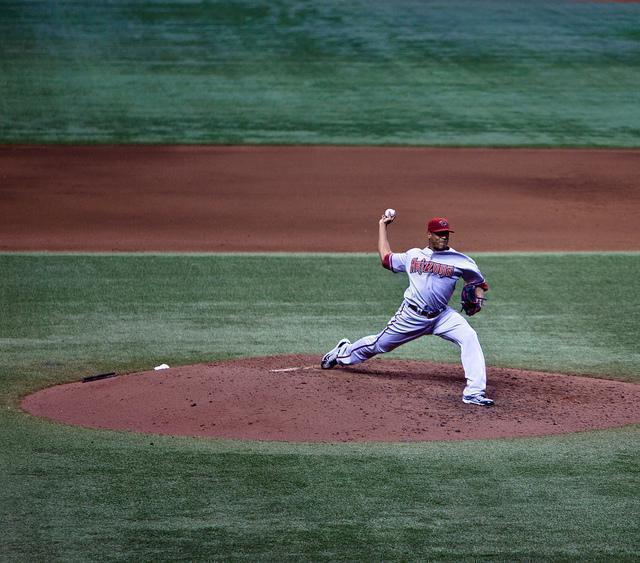What kind of throw is that called?
Choose the right answer and clarify with the format: 'Answer: answer
Rationale: rationale.'
Options: Pitch, underhand, hail mary, hurl. Answer: pitch.
Rationale: The baseball player is on the defensive team. he is throwing the ball from the mound to the catcher at home plate. 